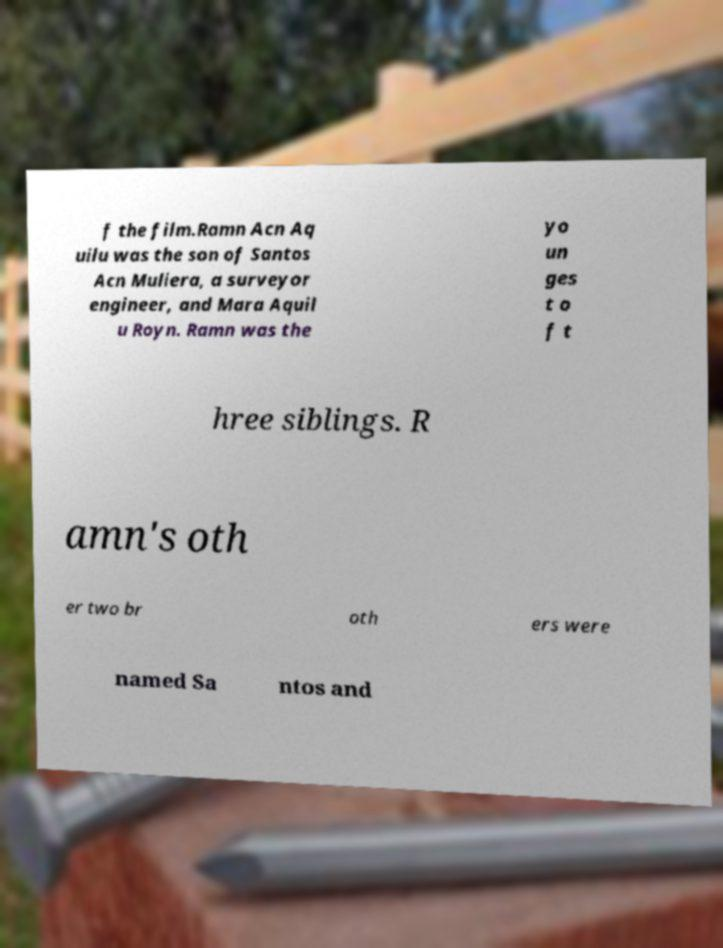Can you accurately transcribe the text from the provided image for me? f the film.Ramn Acn Aq uilu was the son of Santos Acn Muliera, a surveyor engineer, and Mara Aquil u Royn. Ramn was the yo un ges t o f t hree siblings. R amn's oth er two br oth ers were named Sa ntos and 